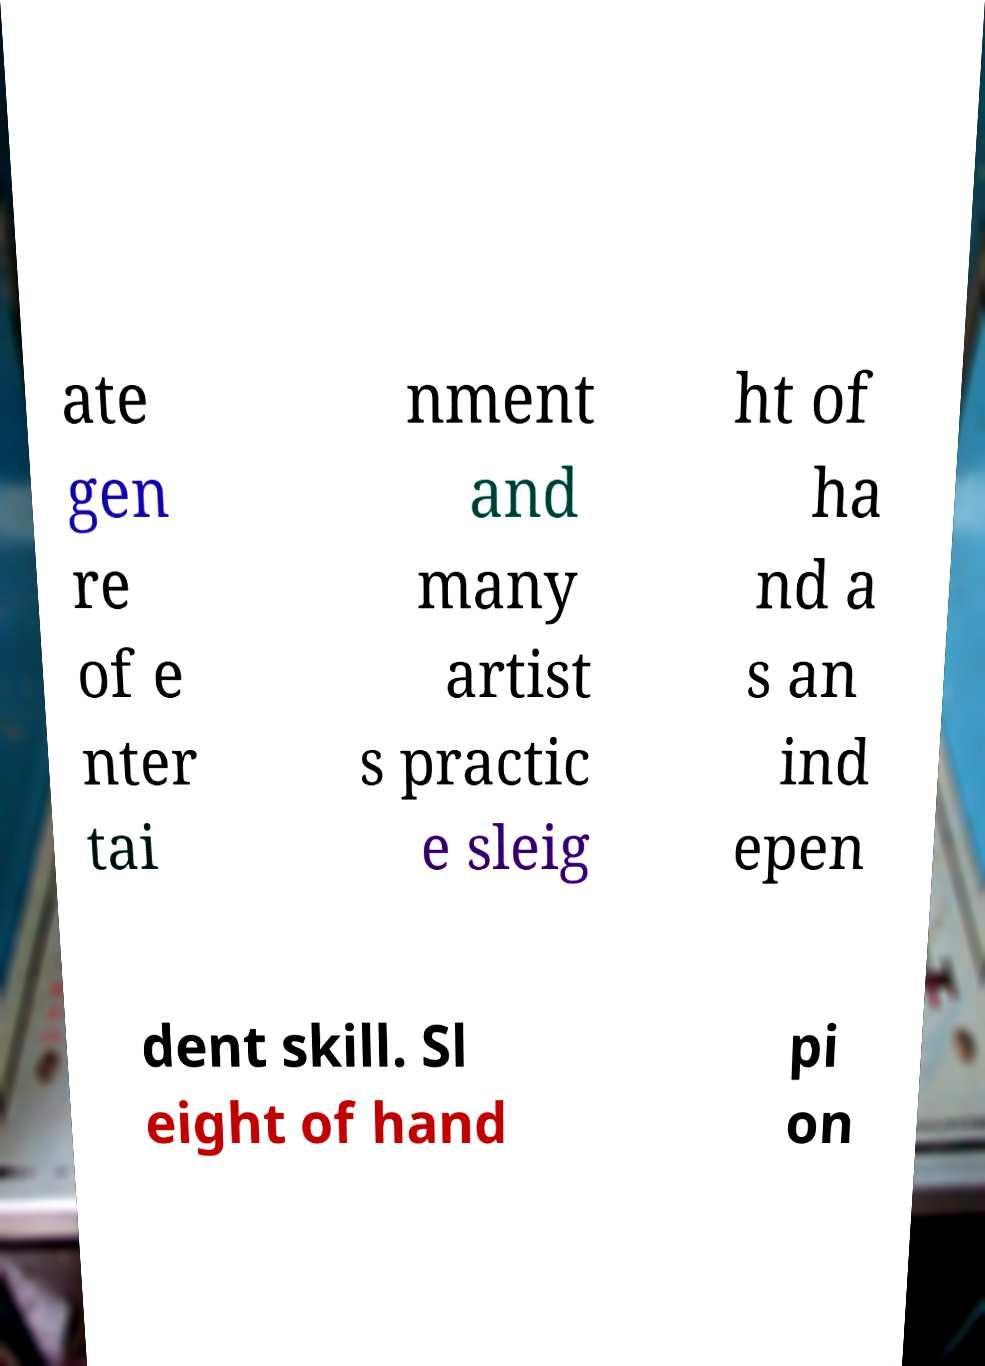For documentation purposes, I need the text within this image transcribed. Could you provide that? ate gen re of e nter tai nment and many artist s practic e sleig ht of ha nd a s an ind epen dent skill. Sl eight of hand pi on 